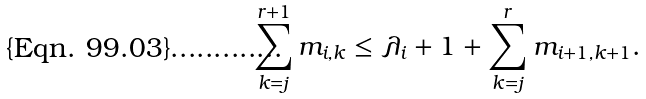<formula> <loc_0><loc_0><loc_500><loc_500>\sum _ { k = j } ^ { r + 1 } m _ { i , k } \leq \lambda _ { i } + 1 + \sum _ { k = j } ^ { r } m _ { i + 1 , k + 1 } .</formula> 